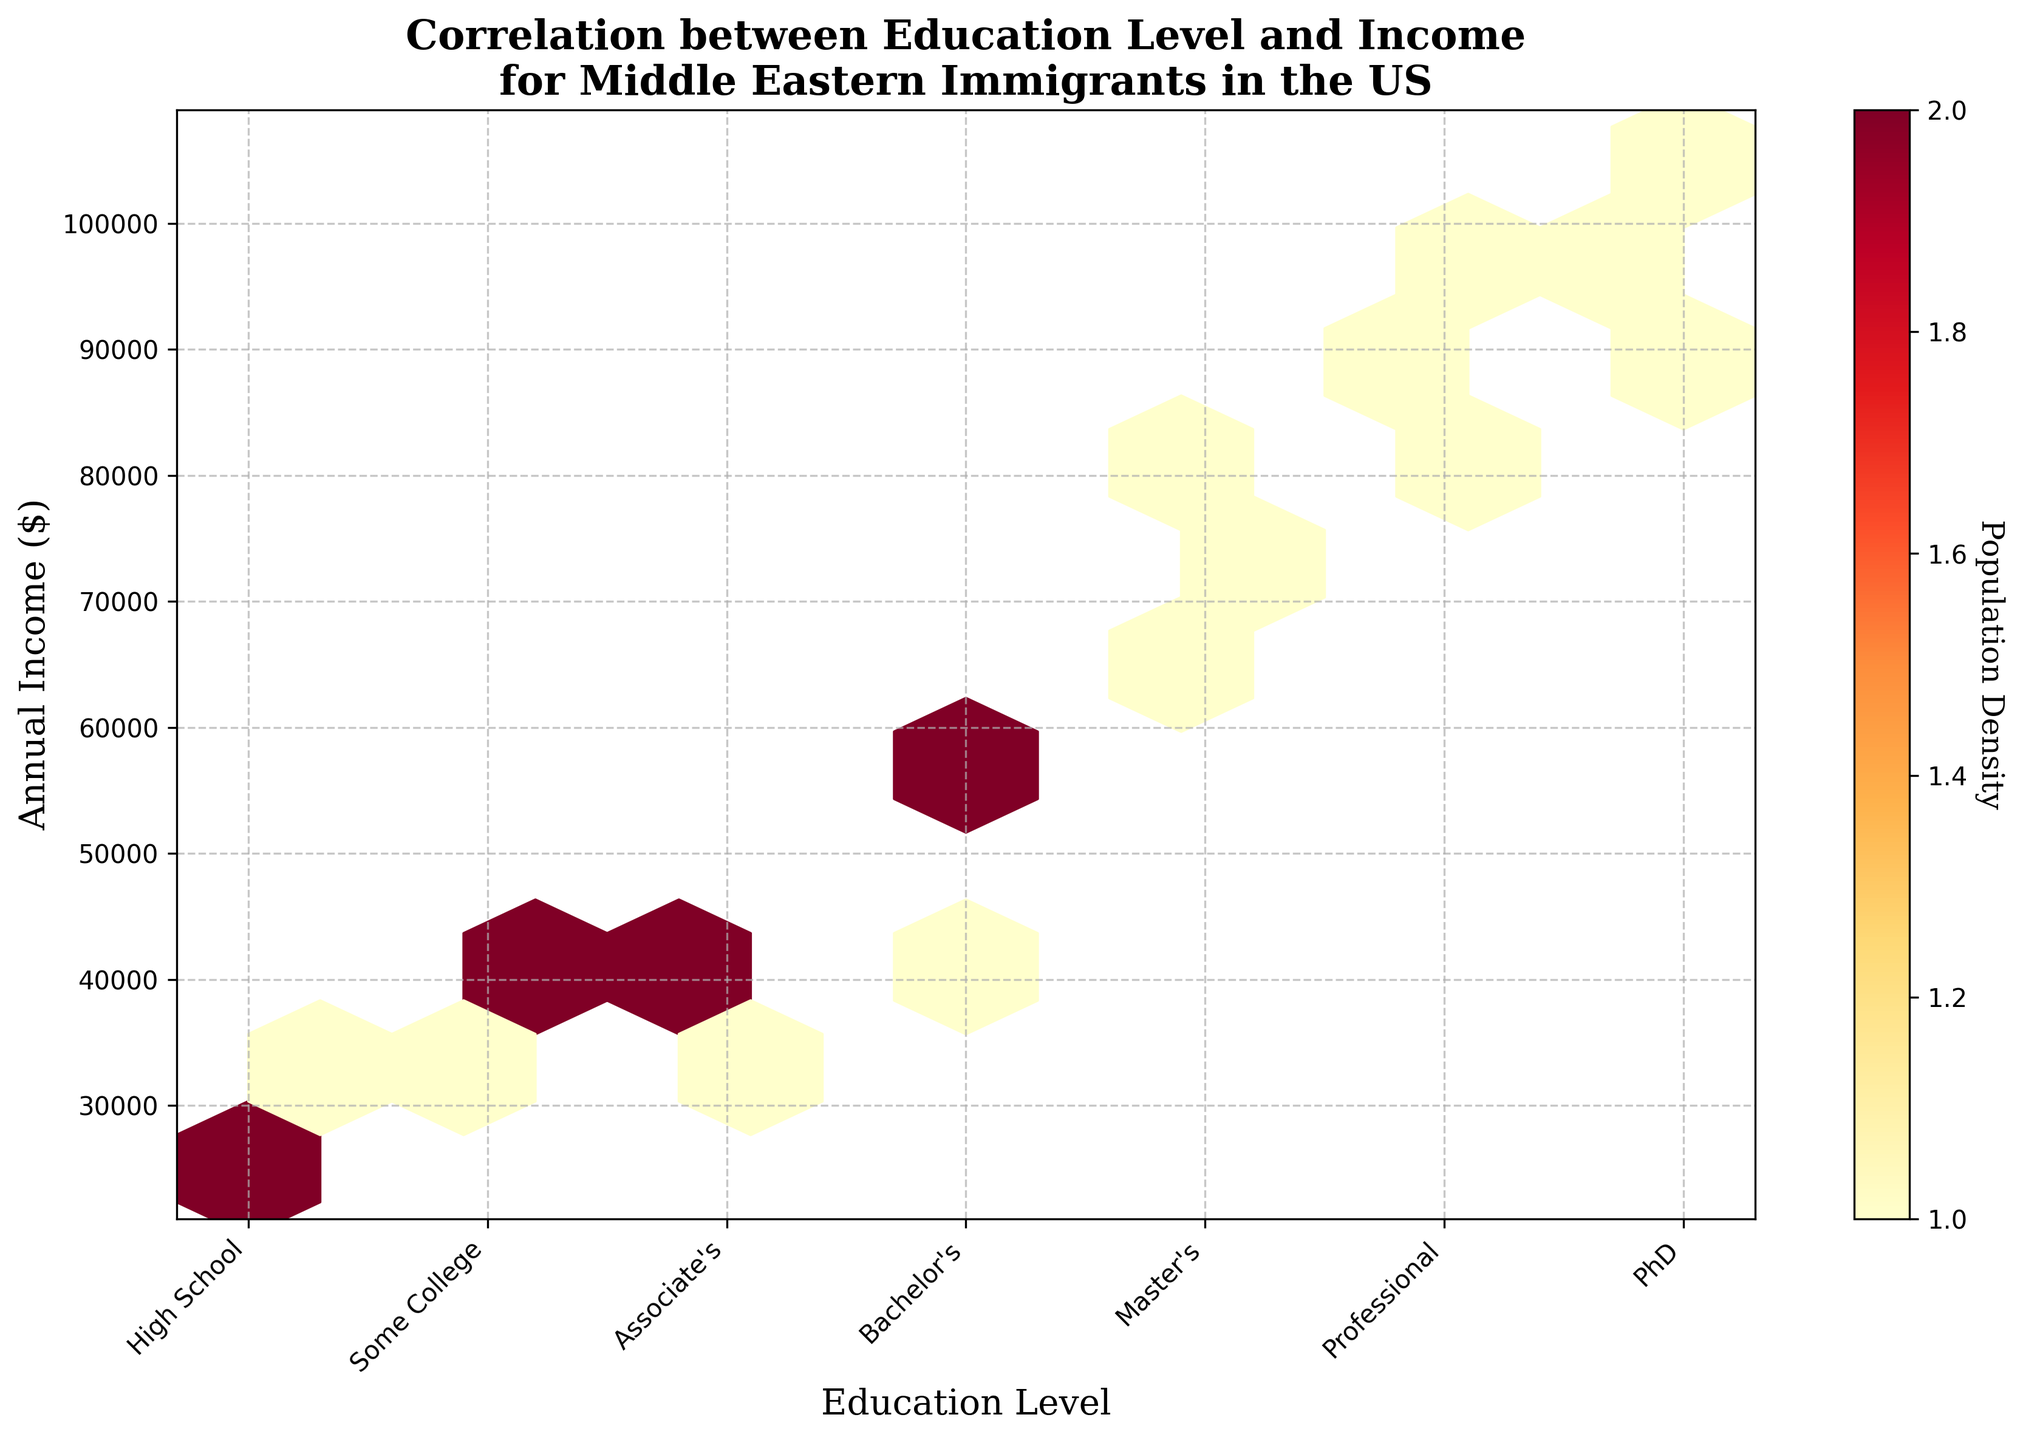What is the title of the plot? The title is placed at the top of the plot. It is written in bold and serif font that clearly states the purpose of the figure.
Answer: "Correlation between Education Level and Income for Middle Eastern Immigrants in the US" Which education level appears on the farthest right of the x-axis? On the x-axis, the farthest right label corresponds to the highest education level indicated. By observing the labels from left to right, we see that the last label is "PhD".
Answer: "PhD" What is the color of the hexagons with the highest population density? The color of the hexagons in a hexbin plot indicates the population density. The legend (color bar) shows that the densest areas are colored dark red.
Answer: Dark red How many education levels are represented on the x-axis? By counting the distinct labels on the x-axis, we can determine the number of different education levels shown. There are seven distinct labels.
Answer: 7 What's the general trend between education level and income? The x-axis represents increasing education levels from left to right, and the y-axis represents annual income. Identifying a general trend involves observing the upward or downward incline of the dense areas as education levels increase. Here, as education levels increase, annual income also appears to rise.
Answer: As education increases, income increases Which education level has the most data points within the $40,000 - $50,000 income range? Firstly, locate the $40,000 to $50,000 range on the y-axis. Then, see which corresponding x-axis label (education level) has the densest hexagons in that range. "Bachelor's Degree" shows the most concentration in this income bracket.
Answer: Bachelor's Degree Are there more hexagons with a high population density at lower or higher education levels? High population density is represented by darker colors. Comparing the density of hexagons at both lower (left side) and higher (right side) x-axis labels, the darker hexagons appear more frequently on the higher education level side.
Answer: Higher education levels Which education level shows the highest income on the plot? By observing the highest point on the y-axis (income) and identifying the corresponding x-axis (education level) label, we can determine that the highest income is associated with the PhD level.
Answer: PhD How does the population density change as education levels increase? The color intensity of hexagons represents population density. Observing the general trend in the colors from left to right along the x-axis shows how the density changes. Initially, it is moderate but becomes higher (darker) as it goes towards higher education levels before slightly decreasing at the highest educational levels such as PhD.
Answer: Increases initially, peaks at Professional Degree, then slightly decreases at PhD What's the income range for someone with a Master's Degree? To identify this, locate the Master's Degree on the x-axis and observe the range of y-values (annual income) that the hexagons span in this section. The income range for a Master's degree spans from approximately $62,000 to $78,000.
Answer: $62,000 to $78,000 